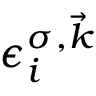<formula> <loc_0><loc_0><loc_500><loc_500>\epsilon _ { i } ^ { \sigma , \vec { k } }</formula> 